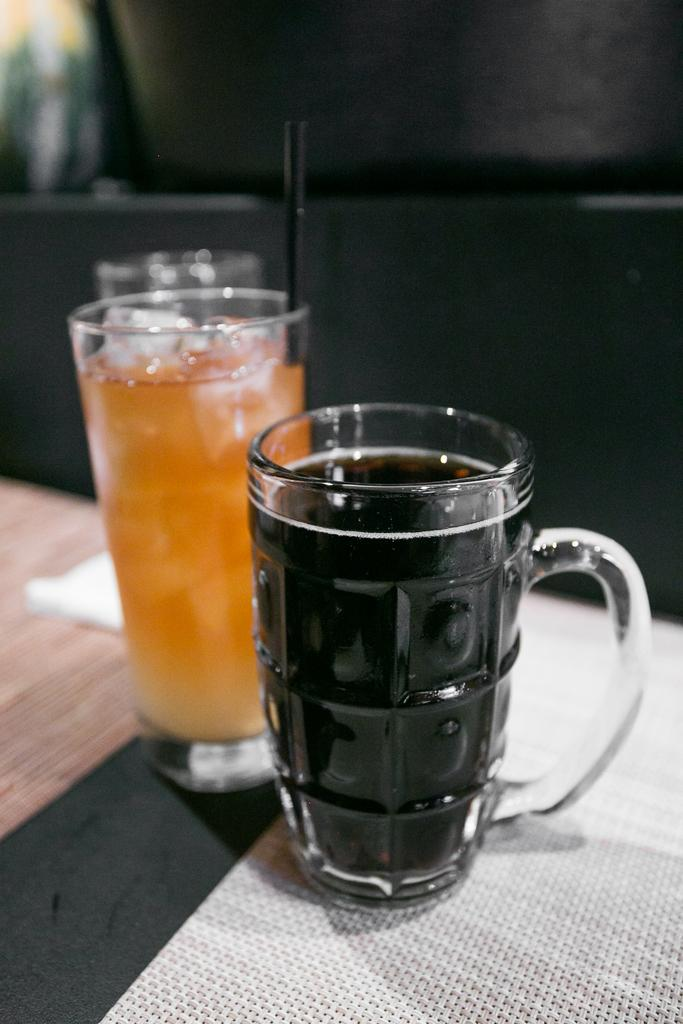What is inside the glasses that are visible in the image? There are glasses with liquid inside them in the image. What is on the table in the image? There is a paper on the table in the image. What can be used to drink the liquid in the glasses? There is a straw in the image. What surface is the paper and glasses resting on? There is a table in the image. What is visible in the background of the image? There is a wall in the image. What type of arch can be seen in the image? There is no arch present in the image. What instrument is the person playing in the image? There is no person or instrument present in the image. 